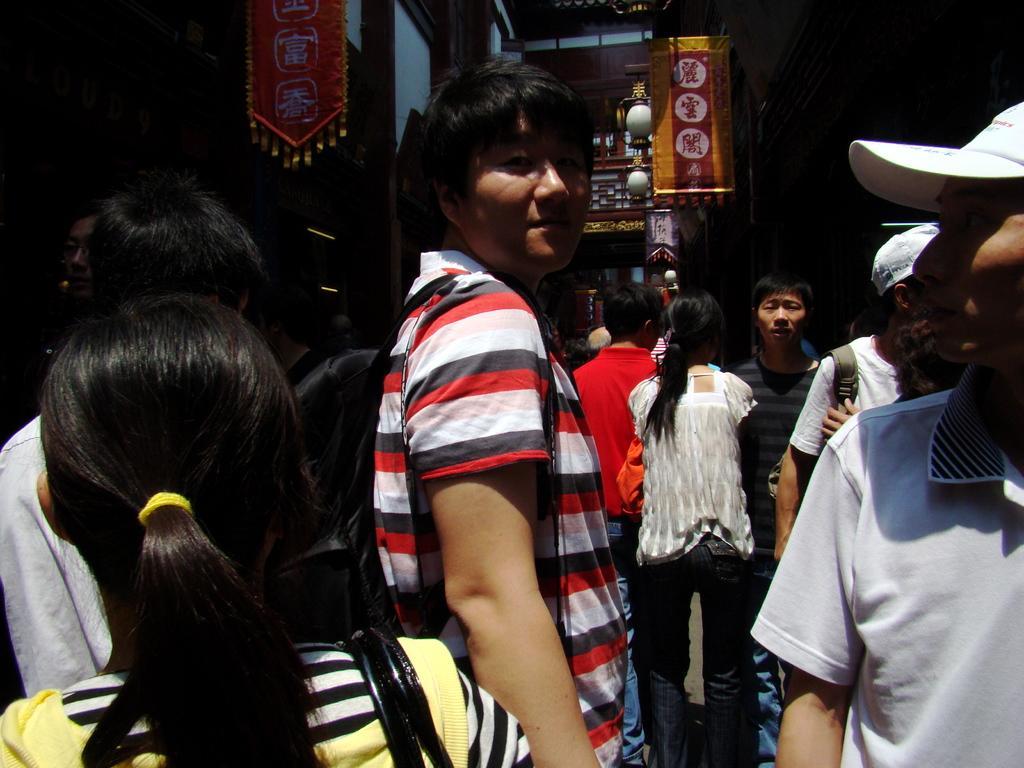Please provide a concise description of this image. This picture describes about group of people, they are standing, in the background we can find few hoardings, lights and buildings. 